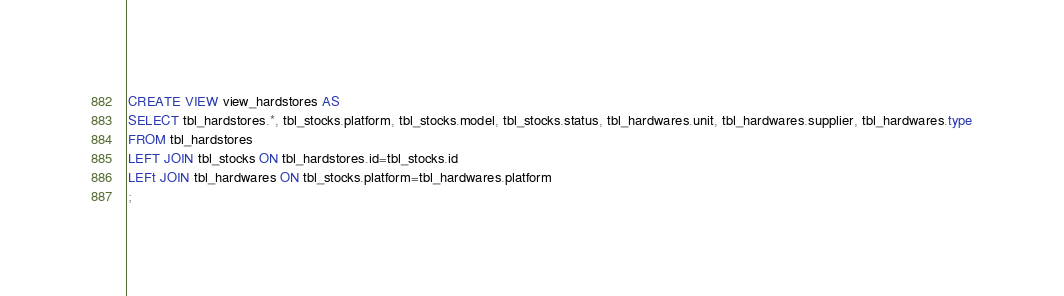Convert code to text. <code><loc_0><loc_0><loc_500><loc_500><_SQL_>CREATE VIEW view_hardstores AS
SELECT tbl_hardstores.*, tbl_stocks.platform, tbl_stocks.model, tbl_stocks.status, tbl_hardwares.unit, tbl_hardwares.supplier, tbl_hardwares.type
FROM tbl_hardstores
LEFT JOIN tbl_stocks ON tbl_hardstores.id=tbl_stocks.id
LEFt JOIN tbl_hardwares ON tbl_stocks.platform=tbl_hardwares.platform
;</code> 